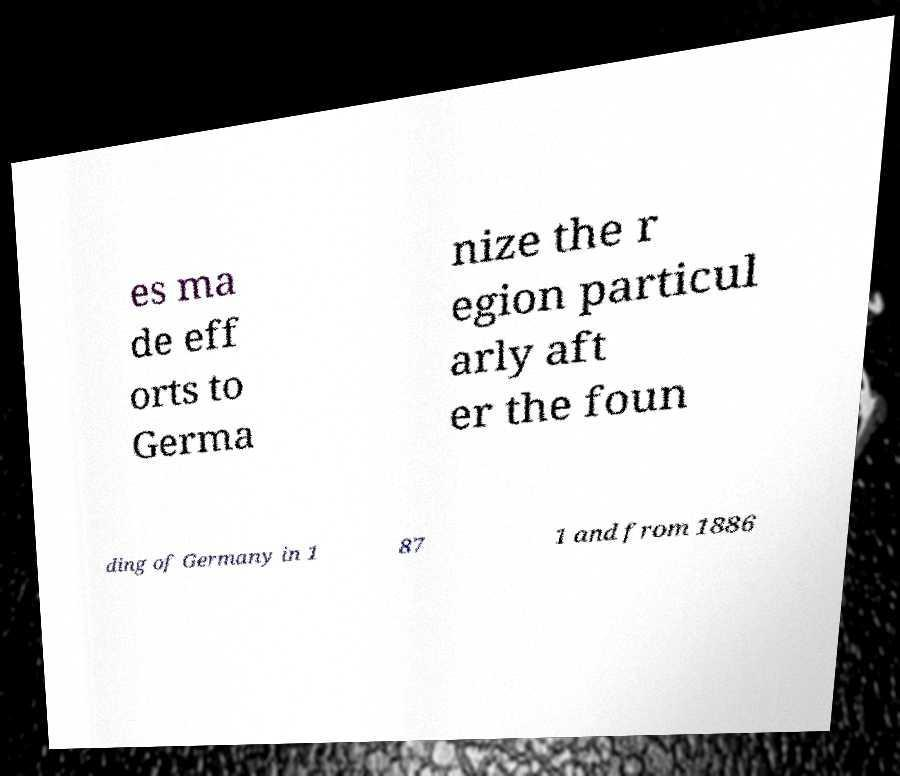Can you read and provide the text displayed in the image?This photo seems to have some interesting text. Can you extract and type it out for me? es ma de eff orts to Germa nize the r egion particul arly aft er the foun ding of Germany in 1 87 1 and from 1886 